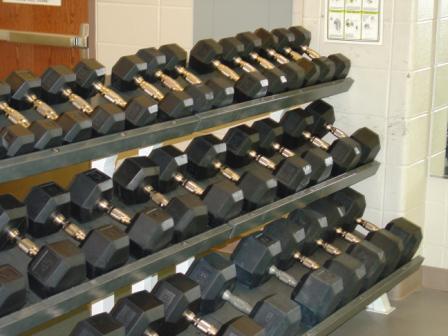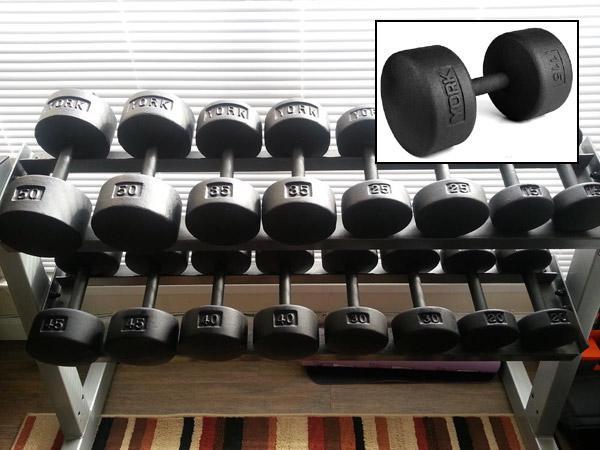The first image is the image on the left, the second image is the image on the right. Given the left and right images, does the statement "In at least one image there is a bar for a bench that has no weights on it." hold true? Answer yes or no. No. The first image is the image on the left, the second image is the image on the right. For the images displayed, is the sentence "Each image contains at least ten black dumbbells, and at least one image shows dumbbells stored on a rack." factually correct? Answer yes or no. Yes. 